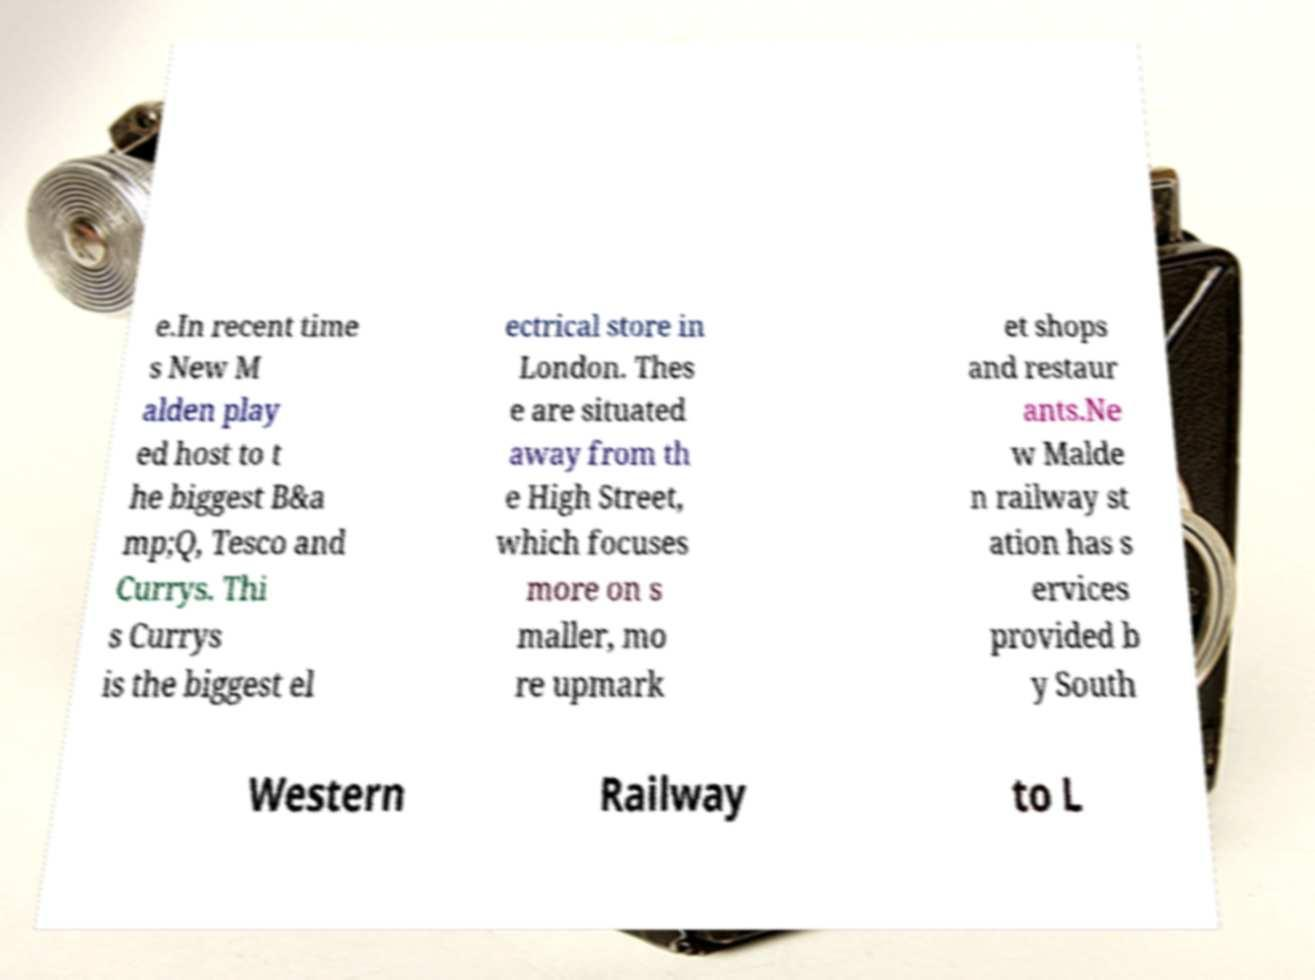Please read and relay the text visible in this image. What does it say? e.In recent time s New M alden play ed host to t he biggest B&a mp;Q, Tesco and Currys. Thi s Currys is the biggest el ectrical store in London. Thes e are situated away from th e High Street, which focuses more on s maller, mo re upmark et shops and restaur ants.Ne w Malde n railway st ation has s ervices provided b y South Western Railway to L 